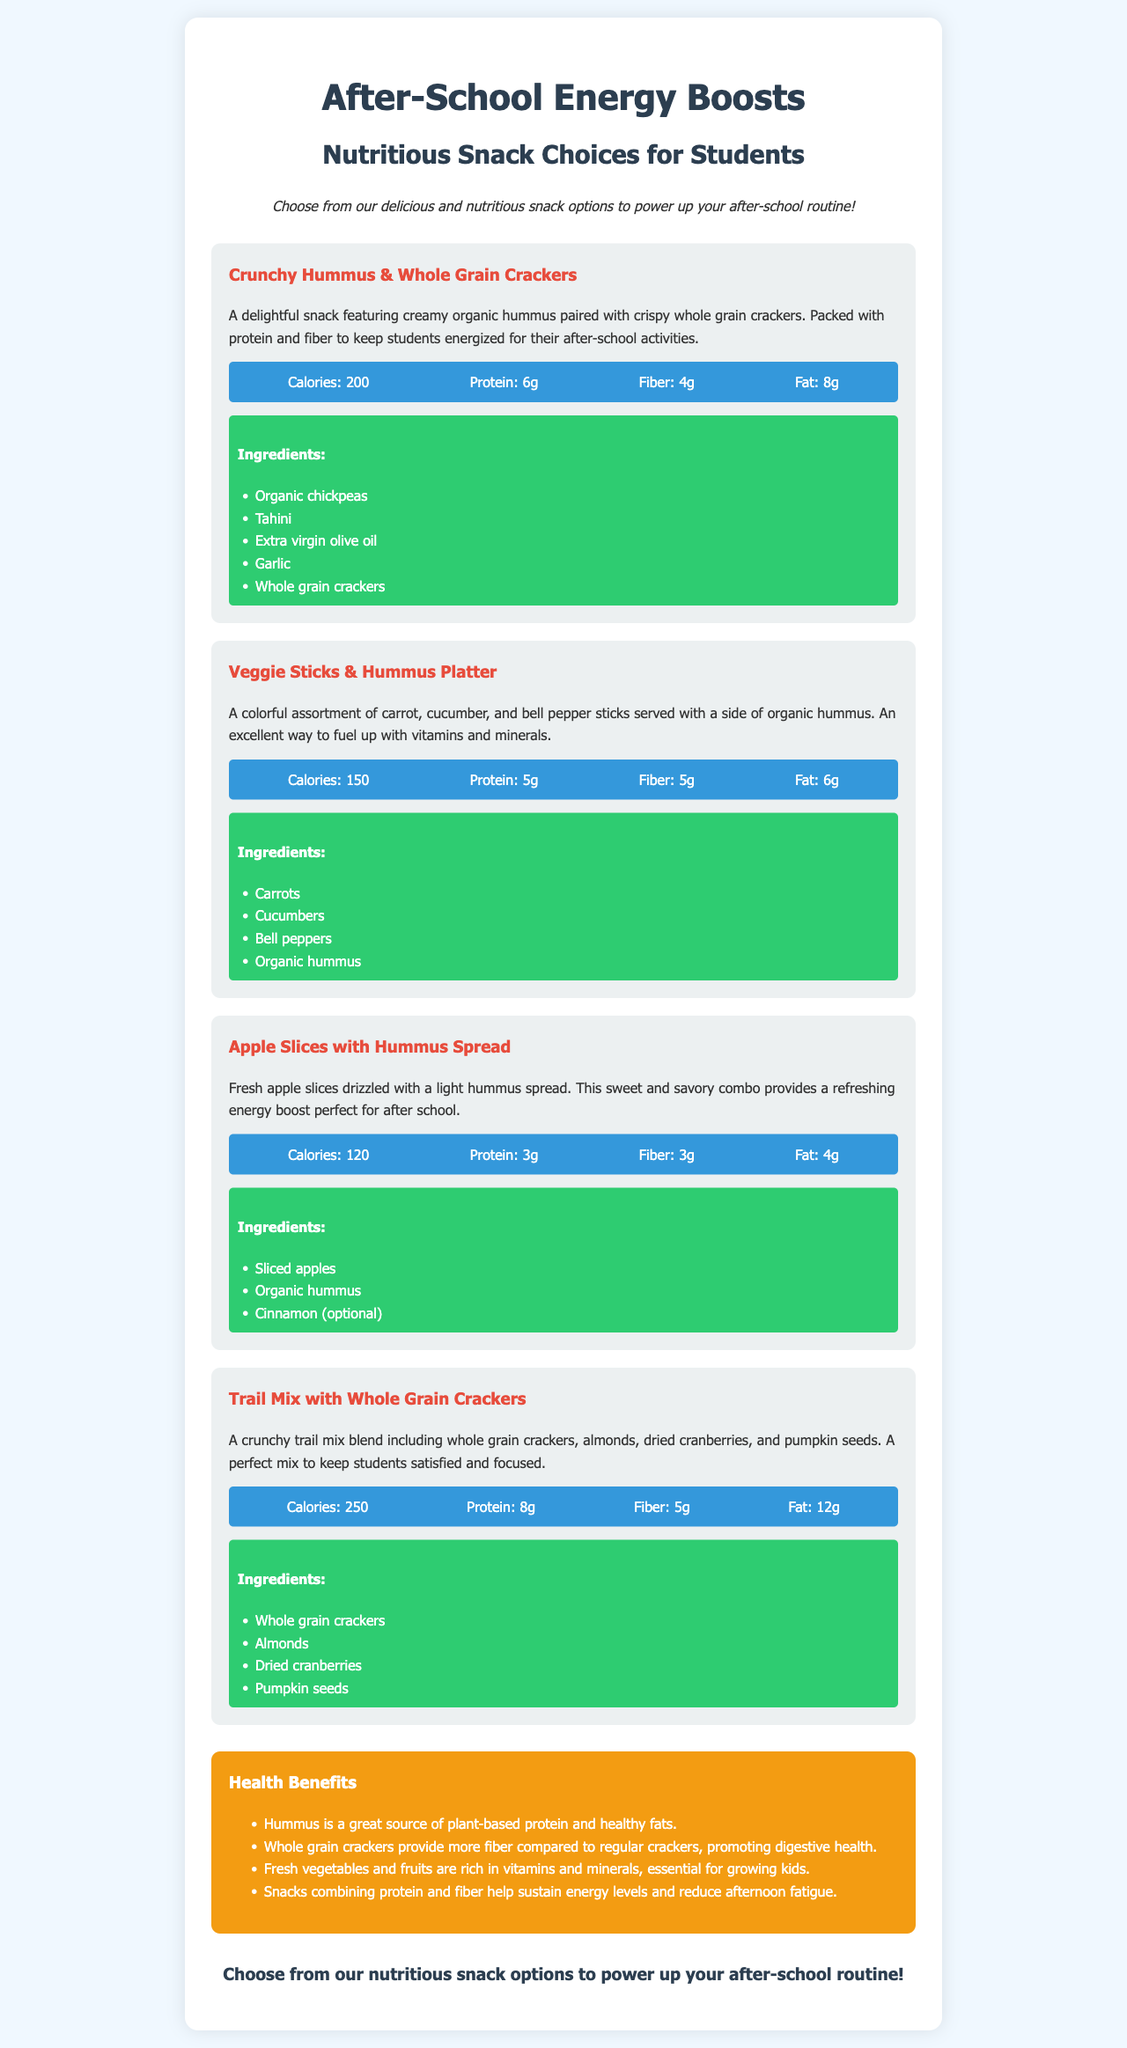What is the main focus of the menu? The main focus of the menu is on nutritious snack choices for students.
Answer: Nutritious snack choices for students How many grams of protein are in Crunchy Hummus & Whole Grain Crackers? The document states that the Crunchy Hummus & Whole Grain Crackers have 6 grams of protein.
Answer: 6g What are the ingredients in the Veggie Sticks & Hummus Platter? The ingredients listed include carrots, cucumbers, bell peppers, and organic hummus.
Answer: Carrots, Cucumbers, Bell peppers, Organic hummus What is the calorie count for Apple Slices with Hummus Spread? The calorie count specified is 120 calories for the Apple Slices with Hummus Spread.
Answer: 120 Which snack provides the most fat? The snack with the highest fat content is the Trail Mix with Whole Grain Crackers, which has 12 grams of fat.
Answer: Trail Mix with Whole Grain Crackers What is a health benefit of hummus mentioned in the menu? The menu indicates that hummus is a great source of plant-based protein and healthy fats.
Answer: Plant-based protein and healthy fats How are the snacks described in the call to action? The call to action encourages choosing nutritious snack options to power up the after-school routine.
Answer: Nutritious snack options What type of food are the whole grain crackers considered? Whole grain crackers are considered a source of more fiber compared to regular crackers.
Answer: Fiber source 